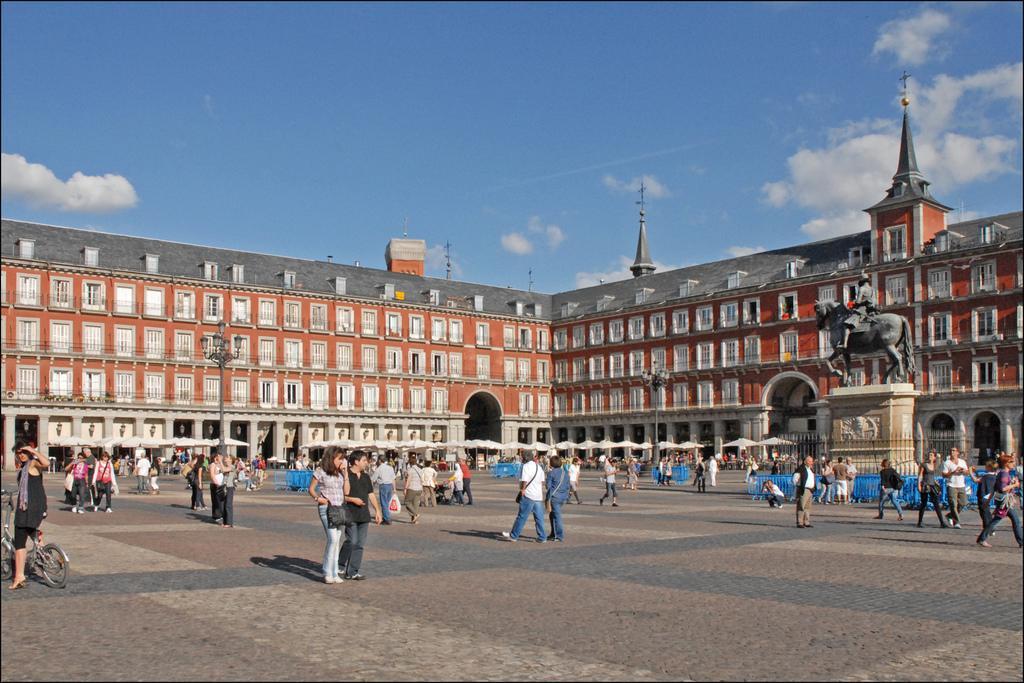Can you describe this image briefly? In this picture we can see some people walking here, on the left side there is a person sitting on the bicycle, in the background there is a building, we can see windows of this building, there is a pole and lights here, there is a statute here, there is sky at the top of the picture, we can see fencing panel hire. 